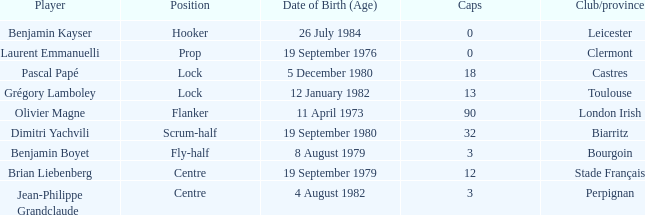When is the 32nd caps' birthday? 19 September 1980. 